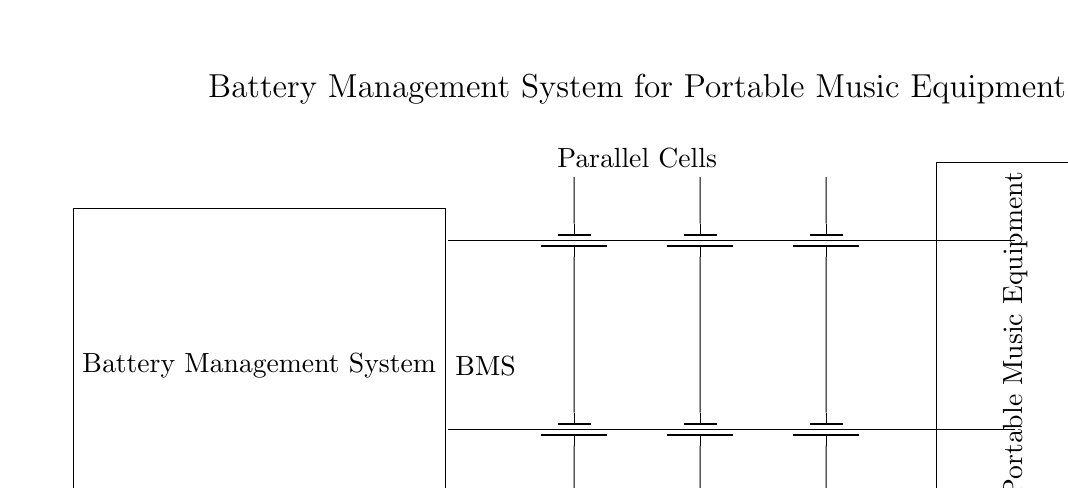What type of cells are used in the system? The diagram shows several battery symbols, which represent battery cells arranged in parallel. This indicates that the energy storage components are batteries.
Answer: Battery cells How many parallel battery cells are there? The circuit diagram displays three battery symbols connected in parallel, indicating the quantity of cells directly.
Answer: Three What does BMS stand for? In the diagram, the rectangle labeled 'Battery Management System' is denoting the role of the BMS, which manages the battery's performance and safety.
Answer: Battery Management System What is the load connected to this circuit? The portable music equipment is shown as a rectangle connected to the parallel battery cells, indicating that it is the device receiving power from the battery system.
Answer: Portable music equipment Why are the battery cells arranged in parallel? Parallel arrangement allows for increased capacity and current supply while maintaining the same voltage, which is essential for applications like music equipment that require higher power without a change in voltage.
Answer: To increase capacity What is the voltage across the portable music equipment? Since the cells are in parallel, the voltage across them remains the same as a single cell. If the individual battery's voltage is not specified in the data, we assume a standard value, but often it will be 1.5V or similar.
Answer: Voltage of a single cell (e.g., 1.5V) What is the purpose of the Battery Management System in this circuit? The BMS monitors the battery’s state, ensures safety during operation, balances the charge across the parallel cells, and protects against overcharging or discharging.
Answer: To manage battery performance 